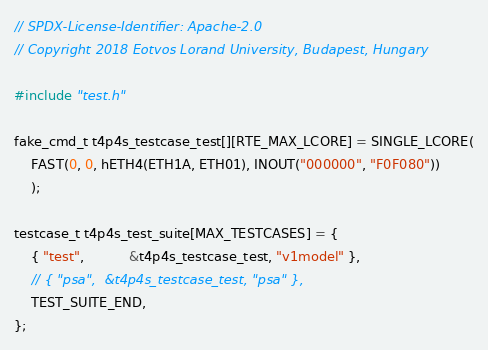Convert code to text. <code><loc_0><loc_0><loc_500><loc_500><_C_>// SPDX-License-Identifier: Apache-2.0
// Copyright 2018 Eotvos Lorand University, Budapest, Hungary

#include "test.h"

fake_cmd_t t4p4s_testcase_test[][RTE_MAX_LCORE] = SINGLE_LCORE(
    FAST(0, 0, hETH4(ETH1A, ETH01), INOUT("000000", "F0F080"))
    );

testcase_t t4p4s_test_suite[MAX_TESTCASES] = {
    { "test",           &t4p4s_testcase_test, "v1model" },
    // { "psa",  &t4p4s_testcase_test, "psa" },
    TEST_SUITE_END,
};
</code> 